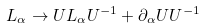Convert formula to latex. <formula><loc_0><loc_0><loc_500><loc_500>L _ { \alpha } \to U L _ { \alpha } U ^ { - 1 } + \partial _ { \alpha } U U ^ { - 1 }</formula> 